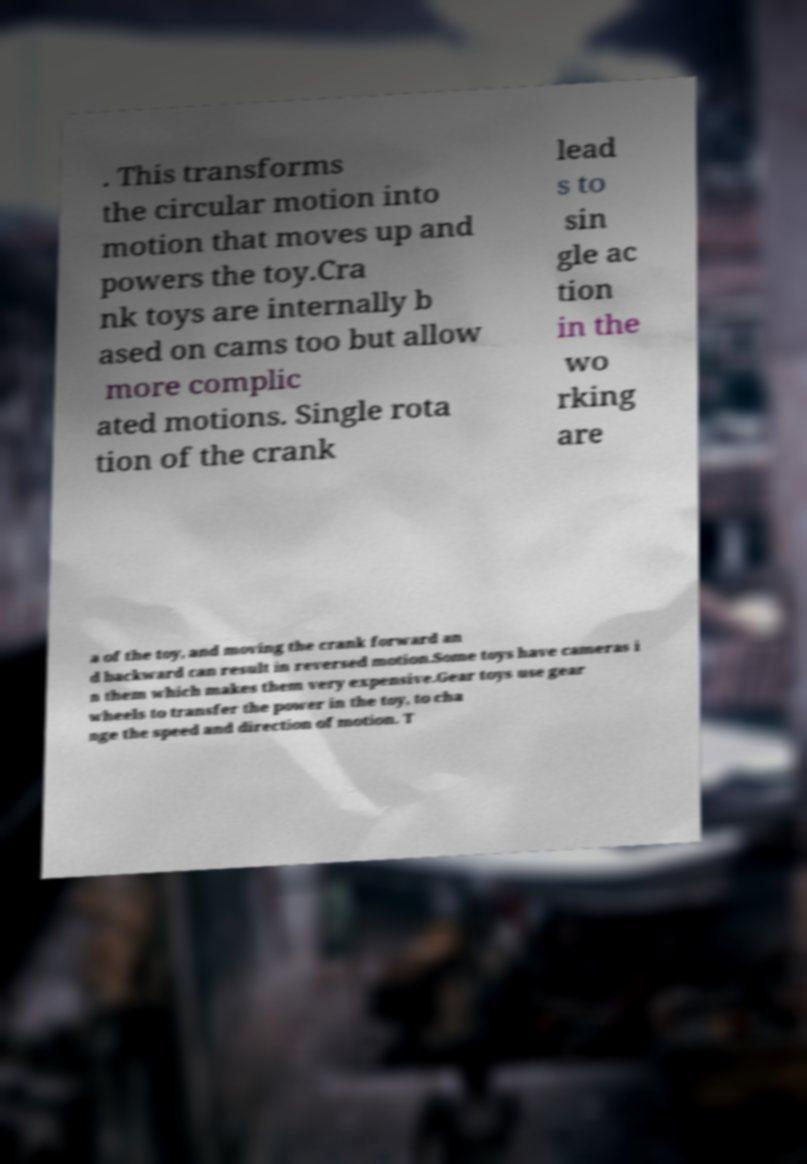Could you extract and type out the text from this image? . This transforms the circular motion into motion that moves up and powers the toy.Cra nk toys are internally b ased on cams too but allow more complic ated motions. Single rota tion of the crank lead s to sin gle ac tion in the wo rking are a of the toy, and moving the crank forward an d backward can result in reversed motion.Some toys have cameras i n them which makes them very expensive.Gear toys use gear wheels to transfer the power in the toy, to cha nge the speed and direction of motion. T 